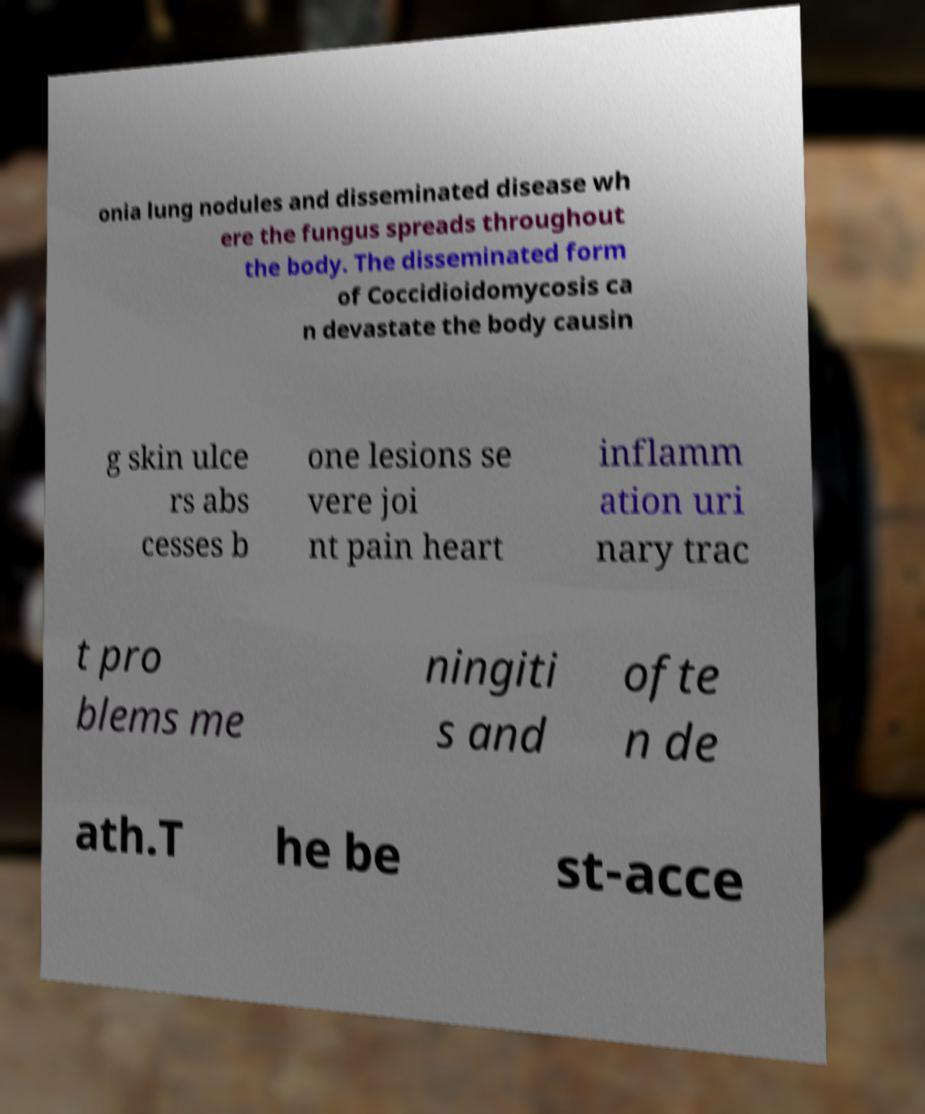Please read and relay the text visible in this image. What does it say? onia lung nodules and disseminated disease wh ere the fungus spreads throughout the body. The disseminated form of Coccidioidomycosis ca n devastate the body causin g skin ulce rs abs cesses b one lesions se vere joi nt pain heart inflamm ation uri nary trac t pro blems me ningiti s and ofte n de ath.T he be st-acce 